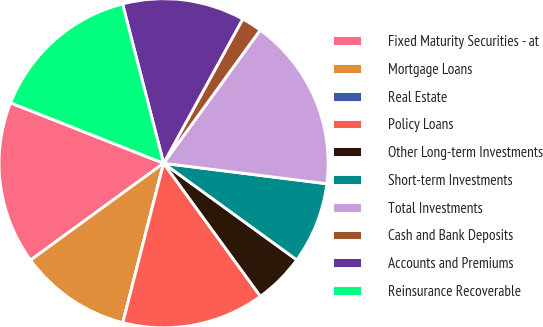Convert chart. <chart><loc_0><loc_0><loc_500><loc_500><pie_chart><fcel>Fixed Maturity Securities - at<fcel>Mortgage Loans<fcel>Real Estate<fcel>Policy Loans<fcel>Other Long-term Investments<fcel>Short-term Investments<fcel>Total Investments<fcel>Cash and Bank Deposits<fcel>Accounts and Premiums<fcel>Reinsurance Recoverable<nl><fcel>16.0%<fcel>11.0%<fcel>0.0%<fcel>14.0%<fcel>5.0%<fcel>8.0%<fcel>17.0%<fcel>2.0%<fcel>12.0%<fcel>15.0%<nl></chart> 